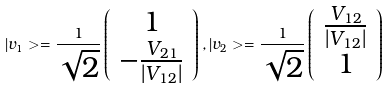<formula> <loc_0><loc_0><loc_500><loc_500>| v _ { 1 } > = \frac { 1 } { \sqrt { 2 } } \left ( \begin{array} { c } 1 \\ - \frac { V _ { 2 1 } } { | V _ { 1 2 } | } \end{array} \right ) , | v _ { 2 } > = \frac { 1 } { \sqrt { 2 } } \left ( \begin{array} { c } \frac { V _ { 1 2 } } { | V _ { 1 2 } | } \\ 1 \end{array} \right )</formula> 